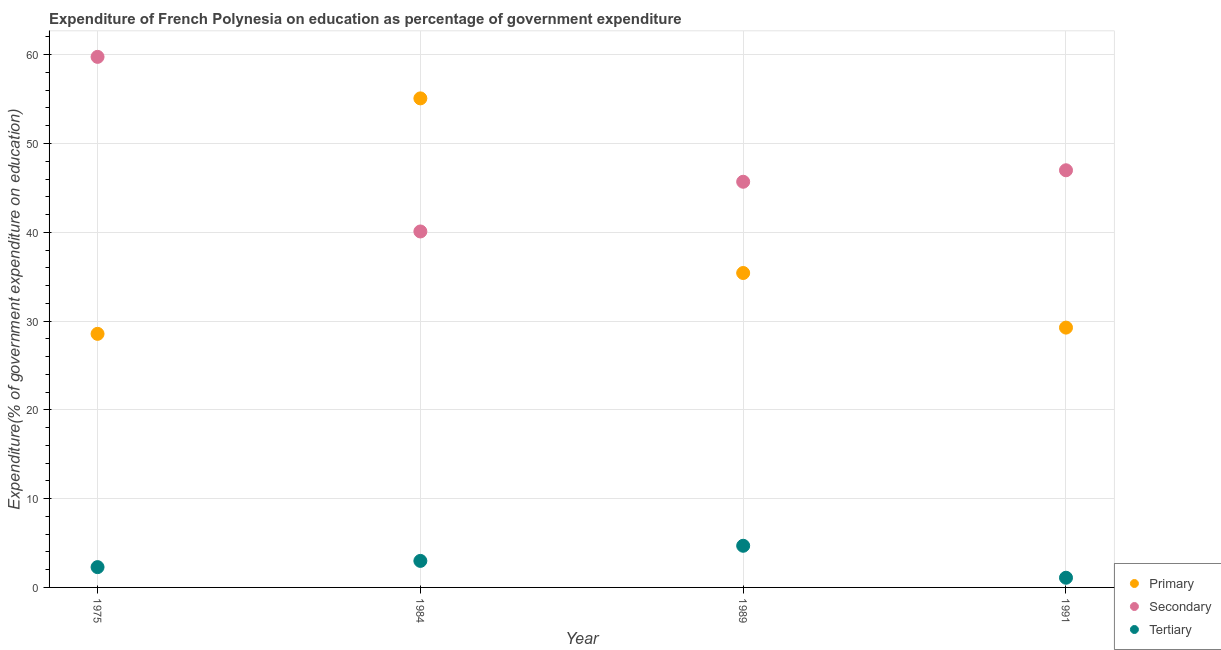What is the expenditure on secondary education in 1984?
Make the answer very short. 40.09. Across all years, what is the maximum expenditure on tertiary education?
Give a very brief answer. 4.69. Across all years, what is the minimum expenditure on tertiary education?
Offer a terse response. 1.09. In which year was the expenditure on secondary education maximum?
Make the answer very short. 1975. What is the total expenditure on tertiary education in the graph?
Your response must be concise. 11.06. What is the difference between the expenditure on secondary education in 1989 and that in 1991?
Provide a succinct answer. -1.29. What is the difference between the expenditure on tertiary education in 1989 and the expenditure on secondary education in 1991?
Give a very brief answer. -42.29. What is the average expenditure on tertiary education per year?
Your answer should be compact. 2.76. In the year 1991, what is the difference between the expenditure on primary education and expenditure on secondary education?
Your response must be concise. -17.72. In how many years, is the expenditure on secondary education greater than 8 %?
Offer a very short reply. 4. What is the ratio of the expenditure on secondary education in 1975 to that in 1984?
Offer a very short reply. 1.49. Is the expenditure on primary education in 1975 less than that in 1991?
Make the answer very short. Yes. Is the difference between the expenditure on primary education in 1989 and 1991 greater than the difference between the expenditure on tertiary education in 1989 and 1991?
Your answer should be very brief. Yes. What is the difference between the highest and the second highest expenditure on tertiary education?
Ensure brevity in your answer.  1.7. What is the difference between the highest and the lowest expenditure on primary education?
Your response must be concise. 26.52. In how many years, is the expenditure on tertiary education greater than the average expenditure on tertiary education taken over all years?
Offer a terse response. 2. Is the sum of the expenditure on secondary education in 1975 and 1991 greater than the maximum expenditure on primary education across all years?
Give a very brief answer. Yes. Is it the case that in every year, the sum of the expenditure on primary education and expenditure on secondary education is greater than the expenditure on tertiary education?
Make the answer very short. Yes. How many legend labels are there?
Give a very brief answer. 3. How are the legend labels stacked?
Make the answer very short. Vertical. What is the title of the graph?
Ensure brevity in your answer.  Expenditure of French Polynesia on education as percentage of government expenditure. What is the label or title of the X-axis?
Offer a terse response. Year. What is the label or title of the Y-axis?
Your answer should be compact. Expenditure(% of government expenditure on education). What is the Expenditure(% of government expenditure on education) in Primary in 1975?
Your response must be concise. 28.56. What is the Expenditure(% of government expenditure on education) of Secondary in 1975?
Keep it short and to the point. 59.76. What is the Expenditure(% of government expenditure on education) in Tertiary in 1975?
Offer a terse response. 2.29. What is the Expenditure(% of government expenditure on education) in Primary in 1984?
Your answer should be very brief. 55.08. What is the Expenditure(% of government expenditure on education) of Secondary in 1984?
Provide a succinct answer. 40.09. What is the Expenditure(% of government expenditure on education) of Tertiary in 1984?
Ensure brevity in your answer.  2.99. What is the Expenditure(% of government expenditure on education) in Primary in 1989?
Offer a very short reply. 35.41. What is the Expenditure(% of government expenditure on education) in Secondary in 1989?
Ensure brevity in your answer.  45.69. What is the Expenditure(% of government expenditure on education) in Tertiary in 1989?
Your answer should be compact. 4.69. What is the Expenditure(% of government expenditure on education) in Primary in 1991?
Your answer should be very brief. 29.26. What is the Expenditure(% of government expenditure on education) of Secondary in 1991?
Ensure brevity in your answer.  46.98. What is the Expenditure(% of government expenditure on education) of Tertiary in 1991?
Give a very brief answer. 1.09. Across all years, what is the maximum Expenditure(% of government expenditure on education) of Primary?
Ensure brevity in your answer.  55.08. Across all years, what is the maximum Expenditure(% of government expenditure on education) in Secondary?
Make the answer very short. 59.76. Across all years, what is the maximum Expenditure(% of government expenditure on education) of Tertiary?
Keep it short and to the point. 4.69. Across all years, what is the minimum Expenditure(% of government expenditure on education) of Primary?
Offer a terse response. 28.56. Across all years, what is the minimum Expenditure(% of government expenditure on education) in Secondary?
Offer a very short reply. 40.09. Across all years, what is the minimum Expenditure(% of government expenditure on education) in Tertiary?
Offer a terse response. 1.09. What is the total Expenditure(% of government expenditure on education) of Primary in the graph?
Your answer should be compact. 148.32. What is the total Expenditure(% of government expenditure on education) in Secondary in the graph?
Ensure brevity in your answer.  192.52. What is the total Expenditure(% of government expenditure on education) in Tertiary in the graph?
Offer a terse response. 11.06. What is the difference between the Expenditure(% of government expenditure on education) in Primary in 1975 and that in 1984?
Give a very brief answer. -26.52. What is the difference between the Expenditure(% of government expenditure on education) in Secondary in 1975 and that in 1984?
Keep it short and to the point. 19.66. What is the difference between the Expenditure(% of government expenditure on education) in Tertiary in 1975 and that in 1984?
Provide a short and direct response. -0.7. What is the difference between the Expenditure(% of government expenditure on education) in Primary in 1975 and that in 1989?
Your answer should be very brief. -6.85. What is the difference between the Expenditure(% of government expenditure on education) of Secondary in 1975 and that in 1989?
Give a very brief answer. 14.07. What is the difference between the Expenditure(% of government expenditure on education) in Tertiary in 1975 and that in 1989?
Give a very brief answer. -2.4. What is the difference between the Expenditure(% of government expenditure on education) of Primary in 1975 and that in 1991?
Offer a terse response. -0.7. What is the difference between the Expenditure(% of government expenditure on education) in Secondary in 1975 and that in 1991?
Your answer should be very brief. 12.77. What is the difference between the Expenditure(% of government expenditure on education) of Tertiary in 1975 and that in 1991?
Offer a terse response. 1.2. What is the difference between the Expenditure(% of government expenditure on education) in Primary in 1984 and that in 1989?
Ensure brevity in your answer.  19.67. What is the difference between the Expenditure(% of government expenditure on education) in Secondary in 1984 and that in 1989?
Provide a succinct answer. -5.6. What is the difference between the Expenditure(% of government expenditure on education) of Tertiary in 1984 and that in 1989?
Offer a very short reply. -1.7. What is the difference between the Expenditure(% of government expenditure on education) of Primary in 1984 and that in 1991?
Provide a short and direct response. 25.82. What is the difference between the Expenditure(% of government expenditure on education) of Secondary in 1984 and that in 1991?
Make the answer very short. -6.89. What is the difference between the Expenditure(% of government expenditure on education) of Tertiary in 1984 and that in 1991?
Provide a succinct answer. 1.9. What is the difference between the Expenditure(% of government expenditure on education) in Primary in 1989 and that in 1991?
Provide a short and direct response. 6.15. What is the difference between the Expenditure(% of government expenditure on education) of Secondary in 1989 and that in 1991?
Provide a short and direct response. -1.29. What is the difference between the Expenditure(% of government expenditure on education) in Tertiary in 1989 and that in 1991?
Keep it short and to the point. 3.6. What is the difference between the Expenditure(% of government expenditure on education) in Primary in 1975 and the Expenditure(% of government expenditure on education) in Secondary in 1984?
Your answer should be compact. -11.53. What is the difference between the Expenditure(% of government expenditure on education) of Primary in 1975 and the Expenditure(% of government expenditure on education) of Tertiary in 1984?
Your response must be concise. 25.57. What is the difference between the Expenditure(% of government expenditure on education) in Secondary in 1975 and the Expenditure(% of government expenditure on education) in Tertiary in 1984?
Your answer should be very brief. 56.77. What is the difference between the Expenditure(% of government expenditure on education) of Primary in 1975 and the Expenditure(% of government expenditure on education) of Secondary in 1989?
Provide a succinct answer. -17.13. What is the difference between the Expenditure(% of government expenditure on education) of Primary in 1975 and the Expenditure(% of government expenditure on education) of Tertiary in 1989?
Your answer should be very brief. 23.87. What is the difference between the Expenditure(% of government expenditure on education) in Secondary in 1975 and the Expenditure(% of government expenditure on education) in Tertiary in 1989?
Your answer should be very brief. 55.07. What is the difference between the Expenditure(% of government expenditure on education) of Primary in 1975 and the Expenditure(% of government expenditure on education) of Secondary in 1991?
Make the answer very short. -18.42. What is the difference between the Expenditure(% of government expenditure on education) in Primary in 1975 and the Expenditure(% of government expenditure on education) in Tertiary in 1991?
Your answer should be very brief. 27.47. What is the difference between the Expenditure(% of government expenditure on education) in Secondary in 1975 and the Expenditure(% of government expenditure on education) in Tertiary in 1991?
Provide a succinct answer. 58.67. What is the difference between the Expenditure(% of government expenditure on education) of Primary in 1984 and the Expenditure(% of government expenditure on education) of Secondary in 1989?
Give a very brief answer. 9.39. What is the difference between the Expenditure(% of government expenditure on education) in Primary in 1984 and the Expenditure(% of government expenditure on education) in Tertiary in 1989?
Make the answer very short. 50.39. What is the difference between the Expenditure(% of government expenditure on education) in Secondary in 1984 and the Expenditure(% of government expenditure on education) in Tertiary in 1989?
Your response must be concise. 35.4. What is the difference between the Expenditure(% of government expenditure on education) of Primary in 1984 and the Expenditure(% of government expenditure on education) of Secondary in 1991?
Make the answer very short. 8.1. What is the difference between the Expenditure(% of government expenditure on education) in Primary in 1984 and the Expenditure(% of government expenditure on education) in Tertiary in 1991?
Your answer should be very brief. 53.99. What is the difference between the Expenditure(% of government expenditure on education) of Secondary in 1984 and the Expenditure(% of government expenditure on education) of Tertiary in 1991?
Offer a terse response. 39. What is the difference between the Expenditure(% of government expenditure on education) in Primary in 1989 and the Expenditure(% of government expenditure on education) in Secondary in 1991?
Offer a very short reply. -11.57. What is the difference between the Expenditure(% of government expenditure on education) in Primary in 1989 and the Expenditure(% of government expenditure on education) in Tertiary in 1991?
Your answer should be very brief. 34.32. What is the difference between the Expenditure(% of government expenditure on education) in Secondary in 1989 and the Expenditure(% of government expenditure on education) in Tertiary in 1991?
Make the answer very short. 44.6. What is the average Expenditure(% of government expenditure on education) in Primary per year?
Your answer should be compact. 37.08. What is the average Expenditure(% of government expenditure on education) of Secondary per year?
Give a very brief answer. 48.13. What is the average Expenditure(% of government expenditure on education) of Tertiary per year?
Offer a very short reply. 2.76. In the year 1975, what is the difference between the Expenditure(% of government expenditure on education) in Primary and Expenditure(% of government expenditure on education) in Secondary?
Give a very brief answer. -31.2. In the year 1975, what is the difference between the Expenditure(% of government expenditure on education) in Primary and Expenditure(% of government expenditure on education) in Tertiary?
Offer a terse response. 26.27. In the year 1975, what is the difference between the Expenditure(% of government expenditure on education) of Secondary and Expenditure(% of government expenditure on education) of Tertiary?
Your answer should be very brief. 57.47. In the year 1984, what is the difference between the Expenditure(% of government expenditure on education) in Primary and Expenditure(% of government expenditure on education) in Secondary?
Keep it short and to the point. 14.99. In the year 1984, what is the difference between the Expenditure(% of government expenditure on education) in Primary and Expenditure(% of government expenditure on education) in Tertiary?
Provide a succinct answer. 52.09. In the year 1984, what is the difference between the Expenditure(% of government expenditure on education) in Secondary and Expenditure(% of government expenditure on education) in Tertiary?
Ensure brevity in your answer.  37.1. In the year 1989, what is the difference between the Expenditure(% of government expenditure on education) of Primary and Expenditure(% of government expenditure on education) of Secondary?
Give a very brief answer. -10.28. In the year 1989, what is the difference between the Expenditure(% of government expenditure on education) of Primary and Expenditure(% of government expenditure on education) of Tertiary?
Ensure brevity in your answer.  30.72. In the year 1989, what is the difference between the Expenditure(% of government expenditure on education) in Secondary and Expenditure(% of government expenditure on education) in Tertiary?
Provide a succinct answer. 41. In the year 1991, what is the difference between the Expenditure(% of government expenditure on education) of Primary and Expenditure(% of government expenditure on education) of Secondary?
Your answer should be compact. -17.72. In the year 1991, what is the difference between the Expenditure(% of government expenditure on education) in Primary and Expenditure(% of government expenditure on education) in Tertiary?
Keep it short and to the point. 28.17. In the year 1991, what is the difference between the Expenditure(% of government expenditure on education) of Secondary and Expenditure(% of government expenditure on education) of Tertiary?
Your answer should be compact. 45.89. What is the ratio of the Expenditure(% of government expenditure on education) in Primary in 1975 to that in 1984?
Your response must be concise. 0.52. What is the ratio of the Expenditure(% of government expenditure on education) in Secondary in 1975 to that in 1984?
Your response must be concise. 1.49. What is the ratio of the Expenditure(% of government expenditure on education) of Tertiary in 1975 to that in 1984?
Make the answer very short. 0.77. What is the ratio of the Expenditure(% of government expenditure on education) in Primary in 1975 to that in 1989?
Your response must be concise. 0.81. What is the ratio of the Expenditure(% of government expenditure on education) of Secondary in 1975 to that in 1989?
Give a very brief answer. 1.31. What is the ratio of the Expenditure(% of government expenditure on education) in Tertiary in 1975 to that in 1989?
Your answer should be compact. 0.49. What is the ratio of the Expenditure(% of government expenditure on education) in Primary in 1975 to that in 1991?
Provide a short and direct response. 0.98. What is the ratio of the Expenditure(% of government expenditure on education) of Secondary in 1975 to that in 1991?
Ensure brevity in your answer.  1.27. What is the ratio of the Expenditure(% of government expenditure on education) in Tertiary in 1975 to that in 1991?
Your answer should be very brief. 2.1. What is the ratio of the Expenditure(% of government expenditure on education) of Primary in 1984 to that in 1989?
Make the answer very short. 1.56. What is the ratio of the Expenditure(% of government expenditure on education) of Secondary in 1984 to that in 1989?
Keep it short and to the point. 0.88. What is the ratio of the Expenditure(% of government expenditure on education) in Tertiary in 1984 to that in 1989?
Ensure brevity in your answer.  0.64. What is the ratio of the Expenditure(% of government expenditure on education) of Primary in 1984 to that in 1991?
Provide a short and direct response. 1.88. What is the ratio of the Expenditure(% of government expenditure on education) in Secondary in 1984 to that in 1991?
Give a very brief answer. 0.85. What is the ratio of the Expenditure(% of government expenditure on education) in Tertiary in 1984 to that in 1991?
Offer a terse response. 2.74. What is the ratio of the Expenditure(% of government expenditure on education) of Primary in 1989 to that in 1991?
Your answer should be very brief. 1.21. What is the ratio of the Expenditure(% of government expenditure on education) of Secondary in 1989 to that in 1991?
Provide a succinct answer. 0.97. What is the ratio of the Expenditure(% of government expenditure on education) in Tertiary in 1989 to that in 1991?
Your answer should be very brief. 4.3. What is the difference between the highest and the second highest Expenditure(% of government expenditure on education) in Primary?
Offer a very short reply. 19.67. What is the difference between the highest and the second highest Expenditure(% of government expenditure on education) of Secondary?
Provide a short and direct response. 12.77. What is the difference between the highest and the second highest Expenditure(% of government expenditure on education) in Tertiary?
Your answer should be very brief. 1.7. What is the difference between the highest and the lowest Expenditure(% of government expenditure on education) in Primary?
Your answer should be very brief. 26.52. What is the difference between the highest and the lowest Expenditure(% of government expenditure on education) of Secondary?
Provide a succinct answer. 19.66. What is the difference between the highest and the lowest Expenditure(% of government expenditure on education) of Tertiary?
Your answer should be very brief. 3.6. 